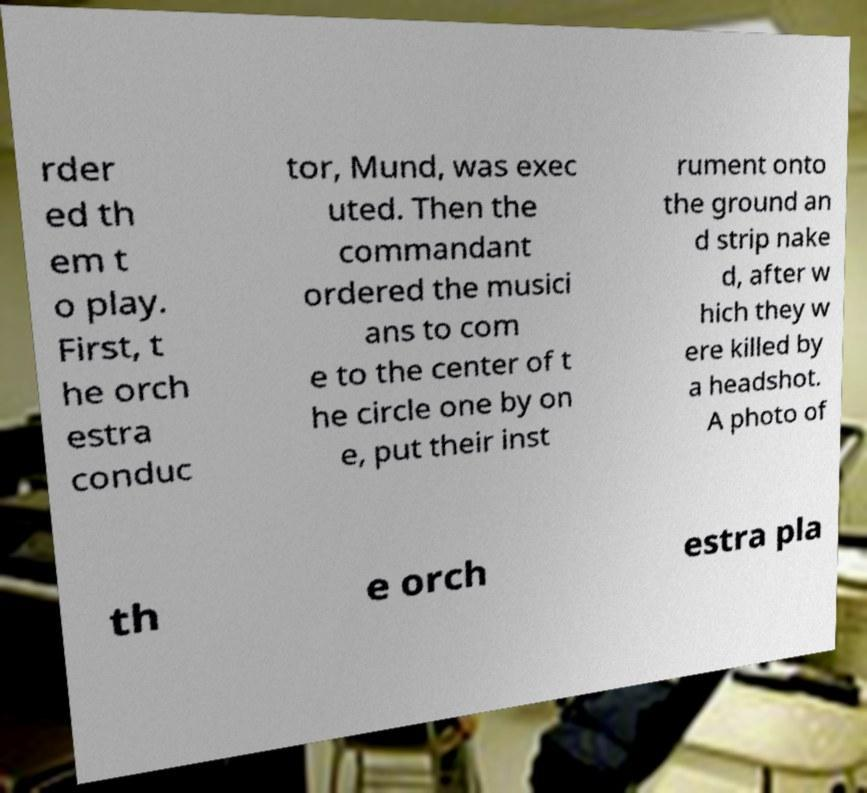Please read and relay the text visible in this image. What does it say? rder ed th em t o play. First, t he orch estra conduc tor, Mund, was exec uted. Then the commandant ordered the musici ans to com e to the center of t he circle one by on e, put their inst rument onto the ground an d strip nake d, after w hich they w ere killed by a headshot. A photo of th e orch estra pla 